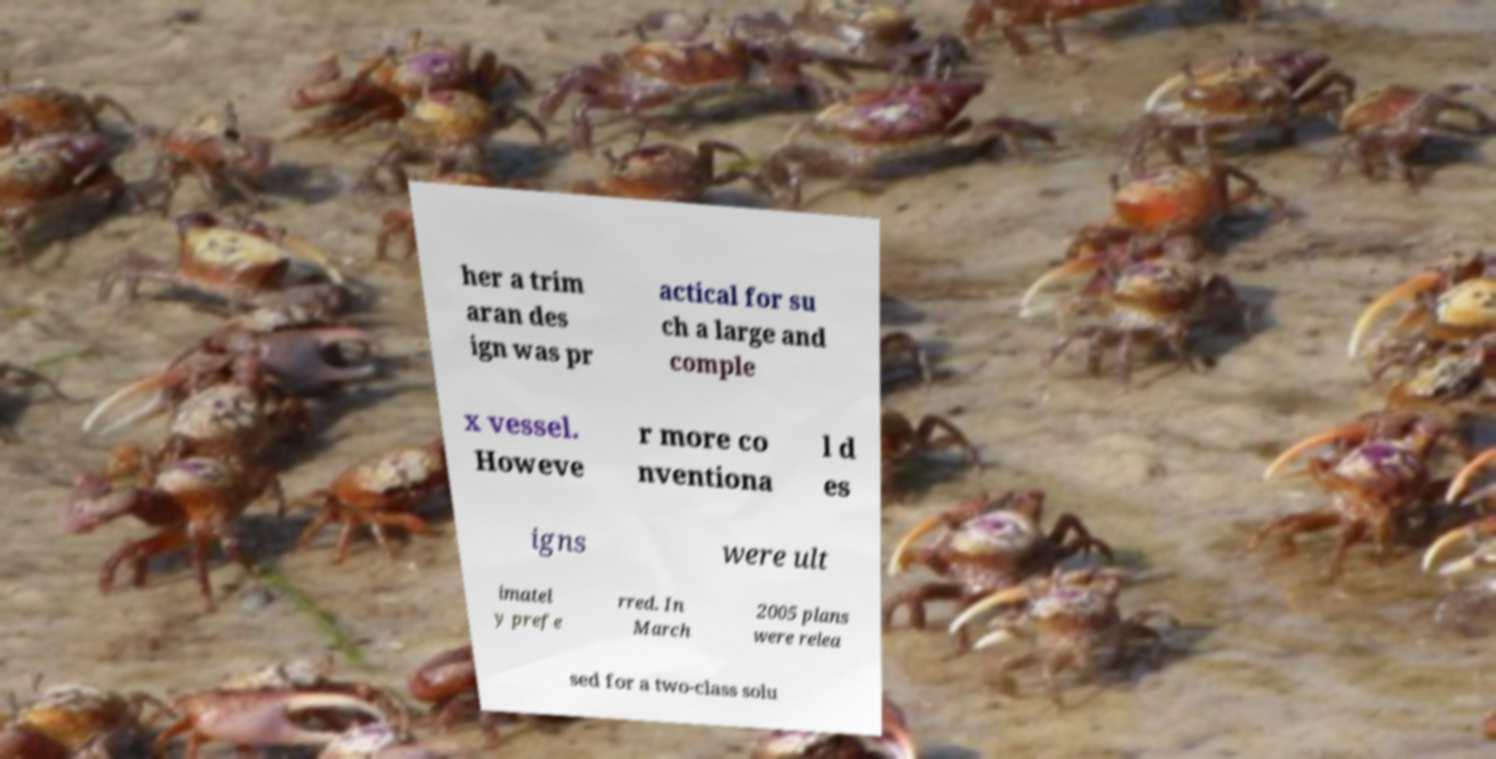I need the written content from this picture converted into text. Can you do that? her a trim aran des ign was pr actical for su ch a large and comple x vessel. Howeve r more co nventiona l d es igns were ult imatel y prefe rred. In March 2005 plans were relea sed for a two-class solu 